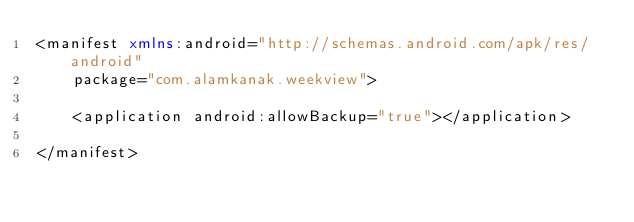<code> <loc_0><loc_0><loc_500><loc_500><_XML_><manifest xmlns:android="http://schemas.android.com/apk/res/android"
    package="com.alamkanak.weekview">

    <application android:allowBackup="true"></application>

</manifest>
</code> 